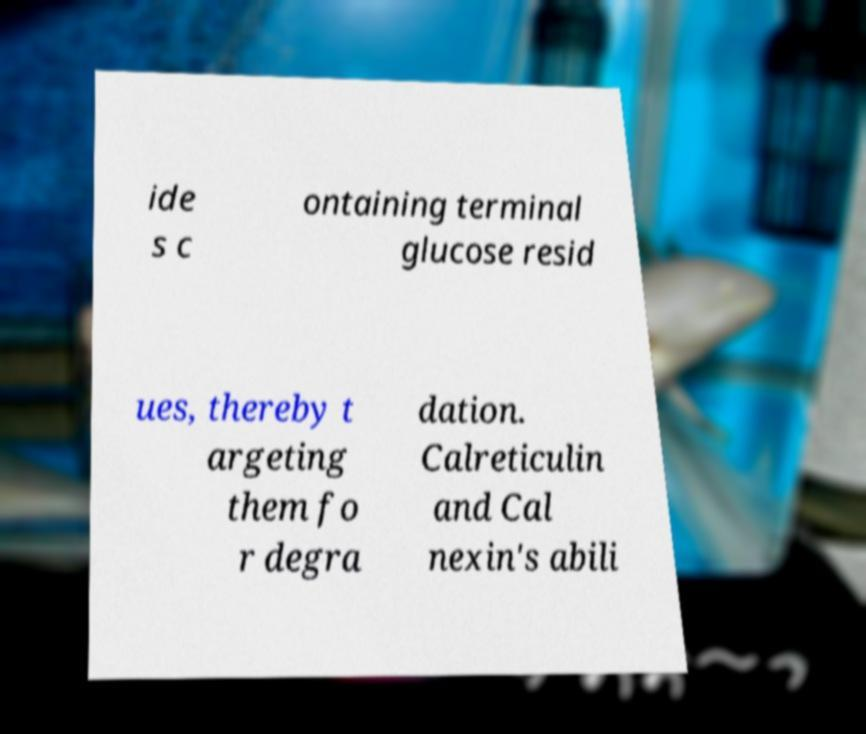Can you accurately transcribe the text from the provided image for me? ide s c ontaining terminal glucose resid ues, thereby t argeting them fo r degra dation. Calreticulin and Cal nexin's abili 